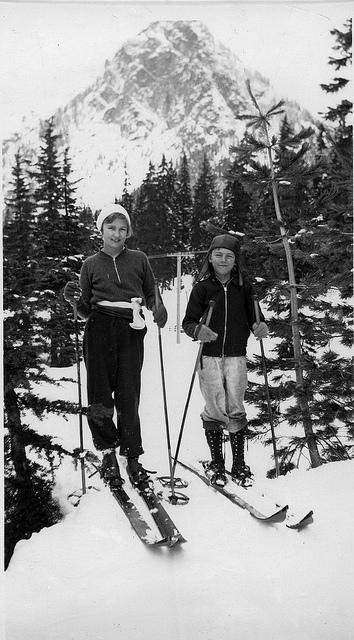How many ski are there?
Give a very brief answer. 2. How many people can be seen?
Give a very brief answer. 2. 